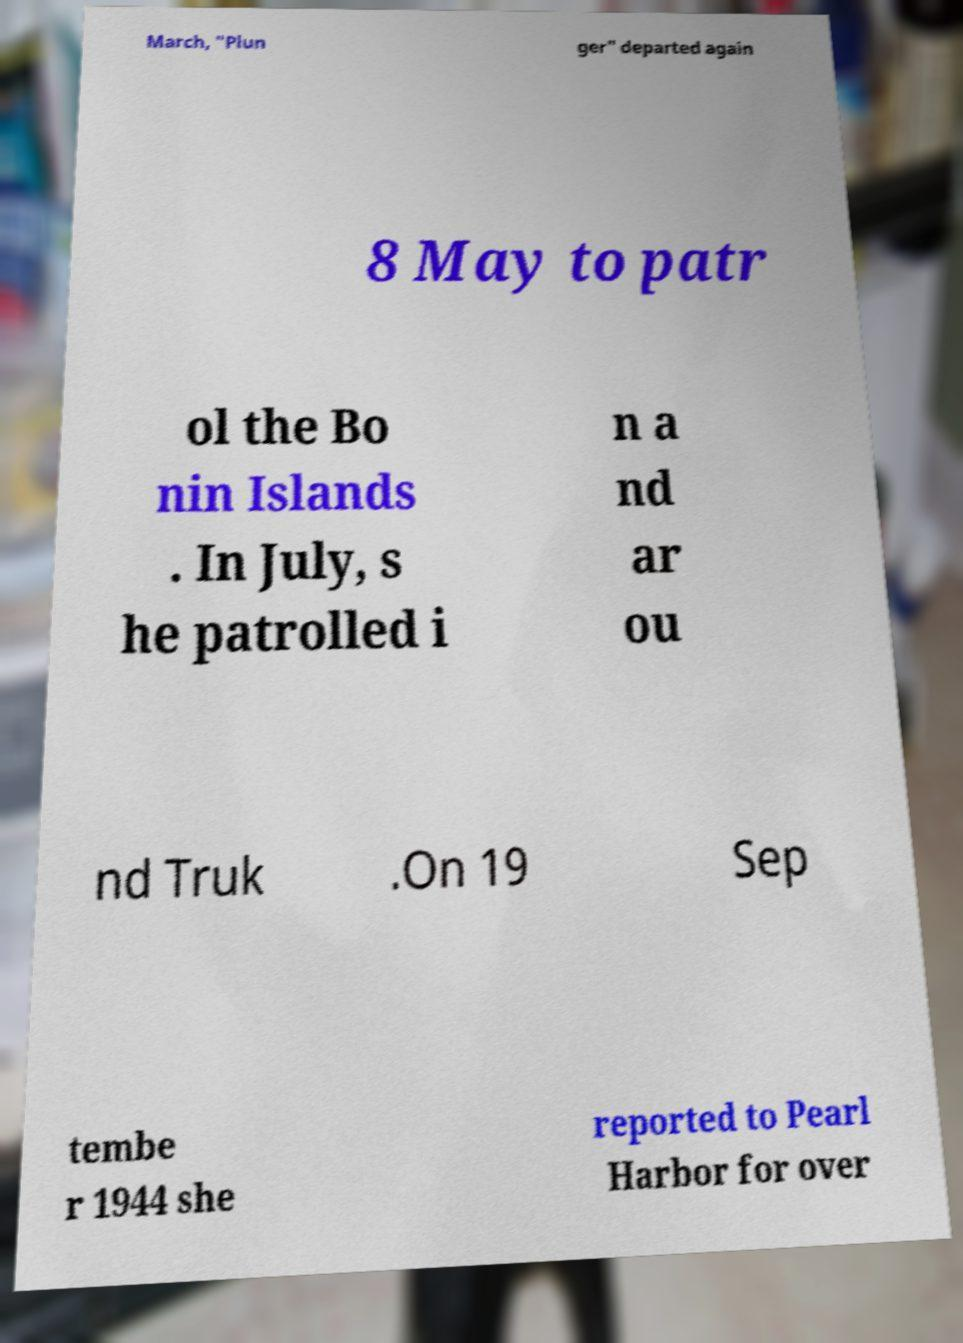There's text embedded in this image that I need extracted. Can you transcribe it verbatim? March, "Plun ger" departed again 8 May to patr ol the Bo nin Islands . In July, s he patrolled i n a nd ar ou nd Truk .On 19 Sep tembe r 1944 she reported to Pearl Harbor for over 